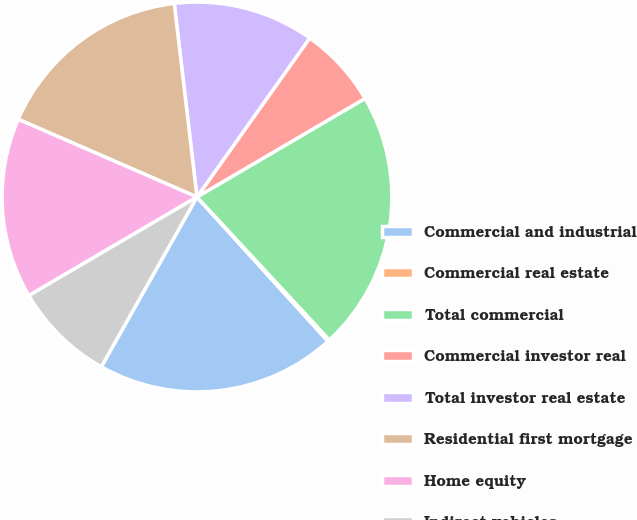Convert chart. <chart><loc_0><loc_0><loc_500><loc_500><pie_chart><fcel>Commercial and industrial<fcel>Commercial real estate<fcel>Total commercial<fcel>Commercial investor real<fcel>Total investor real estate<fcel>Residential first mortgage<fcel>Home equity<fcel>Indirect-vehicles<nl><fcel>19.9%<fcel>0.16%<fcel>21.55%<fcel>6.74%<fcel>11.68%<fcel>16.61%<fcel>14.97%<fcel>8.39%<nl></chart> 